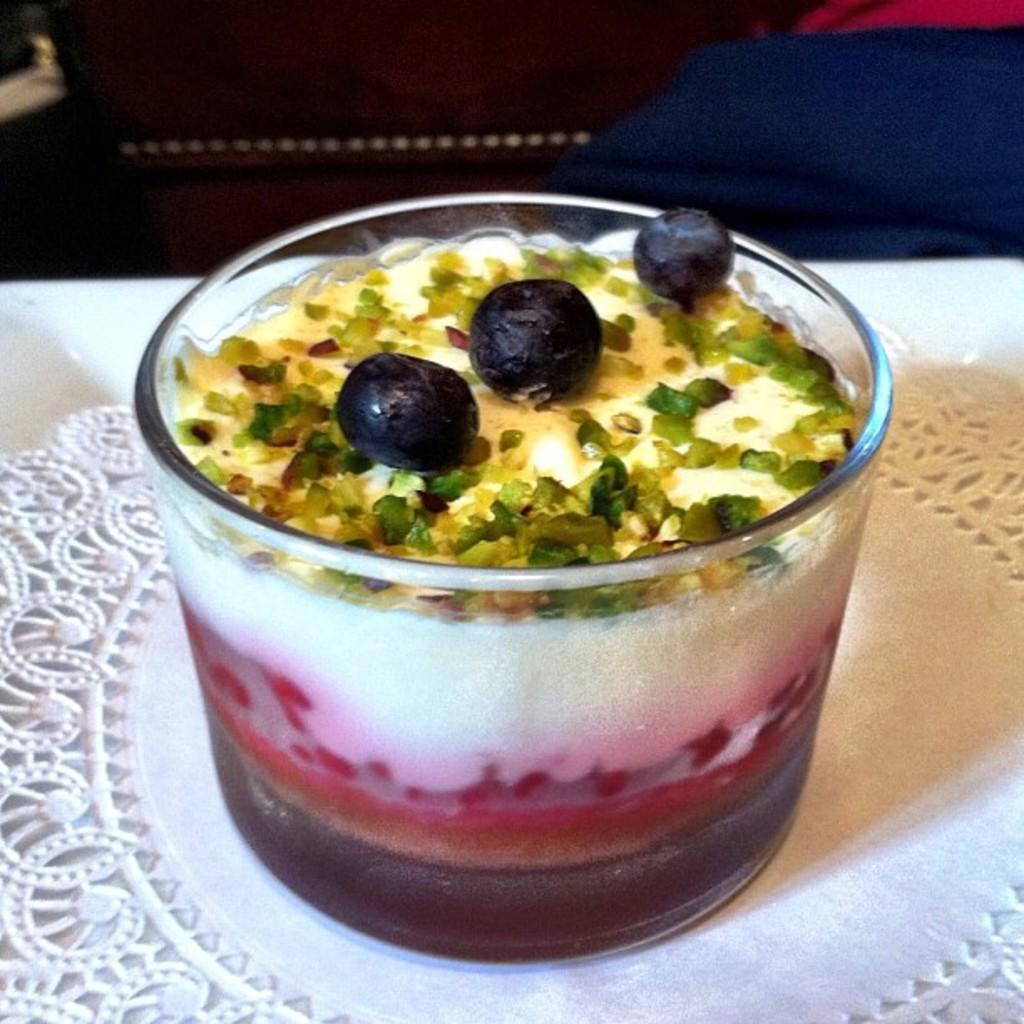What type of dessert is in the glass in the image? The image shows a dessert in a glass, but the specific type of dessert is not mentioned. What is placed under the glass in the image? There is a coaster in the image, which is placed under the glass. Can you describe any objects visible in the background of the image? The facts provided do not mention any specific objects visible in the background of the image. What type of science experiment is being conducted in the image? There is no indication of a science experiment or any scientific activity in the image. 